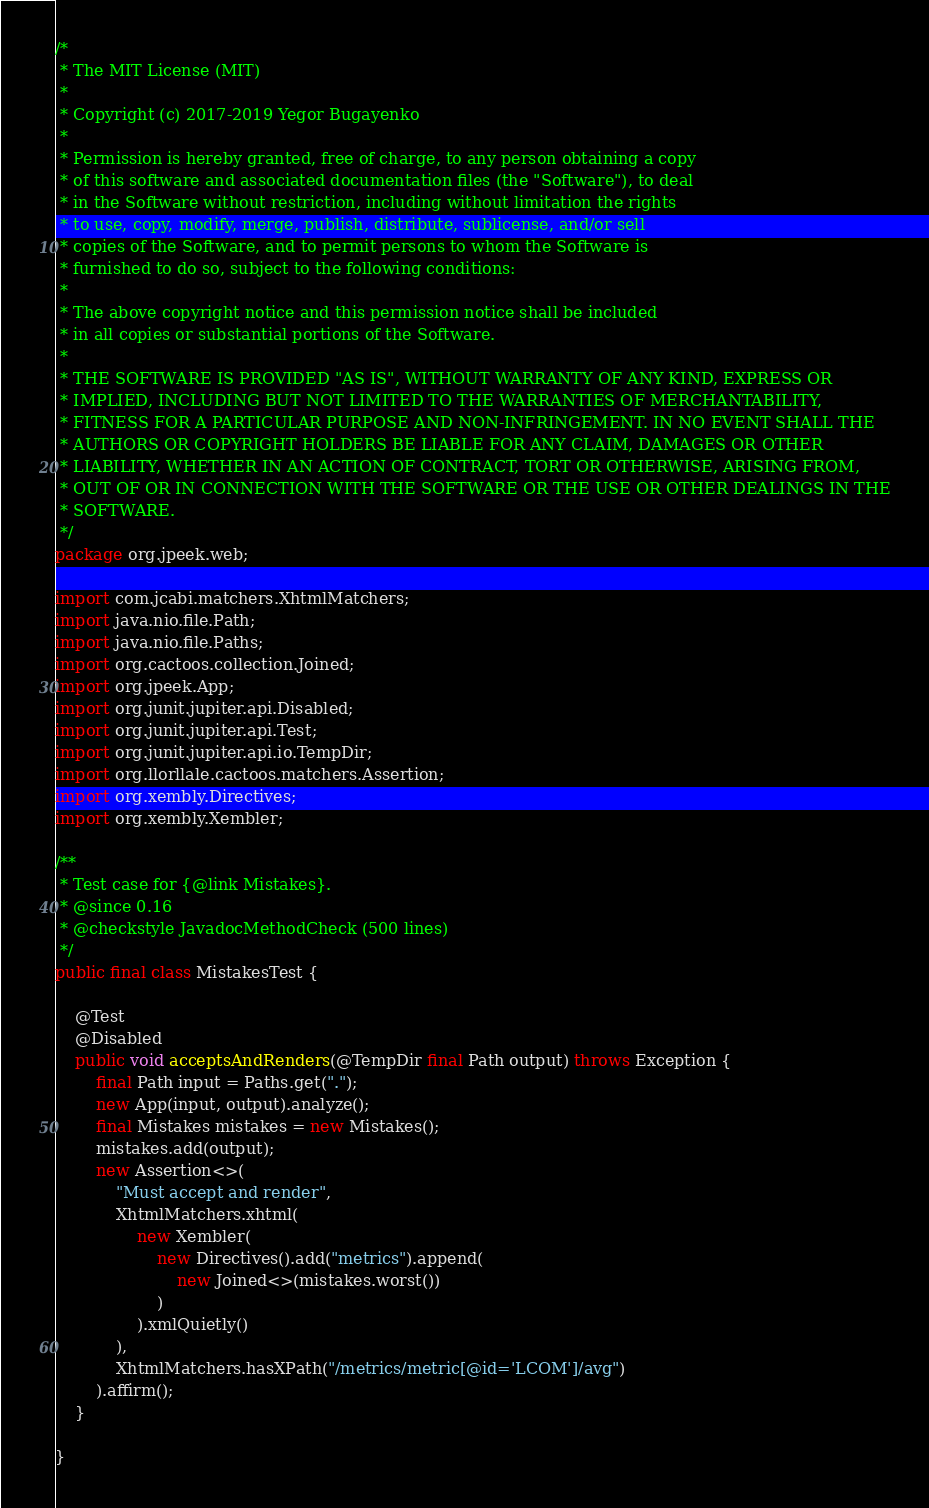Convert code to text. <code><loc_0><loc_0><loc_500><loc_500><_Java_>/*
 * The MIT License (MIT)
 *
 * Copyright (c) 2017-2019 Yegor Bugayenko
 *
 * Permission is hereby granted, free of charge, to any person obtaining a copy
 * of this software and associated documentation files (the "Software"), to deal
 * in the Software without restriction, including without limitation the rights
 * to use, copy, modify, merge, publish, distribute, sublicense, and/or sell
 * copies of the Software, and to permit persons to whom the Software is
 * furnished to do so, subject to the following conditions:
 *
 * The above copyright notice and this permission notice shall be included
 * in all copies or substantial portions of the Software.
 *
 * THE SOFTWARE IS PROVIDED "AS IS", WITHOUT WARRANTY OF ANY KIND, EXPRESS OR
 * IMPLIED, INCLUDING BUT NOT LIMITED TO THE WARRANTIES OF MERCHANTABILITY,
 * FITNESS FOR A PARTICULAR PURPOSE AND NON-INFRINGEMENT. IN NO EVENT SHALL THE
 * AUTHORS OR COPYRIGHT HOLDERS BE LIABLE FOR ANY CLAIM, DAMAGES OR OTHER
 * LIABILITY, WHETHER IN AN ACTION OF CONTRACT, TORT OR OTHERWISE, ARISING FROM,
 * OUT OF OR IN CONNECTION WITH THE SOFTWARE OR THE USE OR OTHER DEALINGS IN THE
 * SOFTWARE.
 */
package org.jpeek.web;

import com.jcabi.matchers.XhtmlMatchers;
import java.nio.file.Path;
import java.nio.file.Paths;
import org.cactoos.collection.Joined;
import org.jpeek.App;
import org.junit.jupiter.api.Disabled;
import org.junit.jupiter.api.Test;
import org.junit.jupiter.api.io.TempDir;
import org.llorllale.cactoos.matchers.Assertion;
import org.xembly.Directives;
import org.xembly.Xembler;

/**
 * Test case for {@link Mistakes}.
 * @since 0.16
 * @checkstyle JavadocMethodCheck (500 lines)
 */
public final class MistakesTest {

    @Test
    @Disabled
    public void acceptsAndRenders(@TempDir final Path output) throws Exception {
        final Path input = Paths.get(".");
        new App(input, output).analyze();
        final Mistakes mistakes = new Mistakes();
        mistakes.add(output);
        new Assertion<>(
            "Must accept and render",
            XhtmlMatchers.xhtml(
                new Xembler(
                    new Directives().add("metrics").append(
                        new Joined<>(mistakes.worst())
                    )
                ).xmlQuietly()
            ),
            XhtmlMatchers.hasXPath("/metrics/metric[@id='LCOM']/avg")
        ).affirm();
    }

}
</code> 